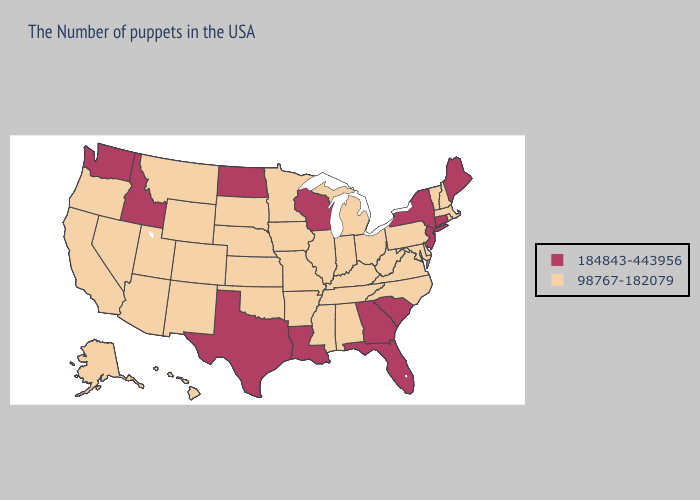Does Oregon have the same value as Minnesota?
Short answer required. Yes. Does New Jersey have the highest value in the Northeast?
Be succinct. Yes. Name the states that have a value in the range 184843-443956?
Be succinct. Maine, Connecticut, New York, New Jersey, South Carolina, Florida, Georgia, Wisconsin, Louisiana, Texas, North Dakota, Idaho, Washington. Name the states that have a value in the range 184843-443956?
Concise answer only. Maine, Connecticut, New York, New Jersey, South Carolina, Florida, Georgia, Wisconsin, Louisiana, Texas, North Dakota, Idaho, Washington. Name the states that have a value in the range 98767-182079?
Keep it brief. Massachusetts, Rhode Island, New Hampshire, Vermont, Delaware, Maryland, Pennsylvania, Virginia, North Carolina, West Virginia, Ohio, Michigan, Kentucky, Indiana, Alabama, Tennessee, Illinois, Mississippi, Missouri, Arkansas, Minnesota, Iowa, Kansas, Nebraska, Oklahoma, South Dakota, Wyoming, Colorado, New Mexico, Utah, Montana, Arizona, Nevada, California, Oregon, Alaska, Hawaii. Does Colorado have a higher value than Iowa?
Concise answer only. No. Does Idaho have the lowest value in the USA?
Answer briefly. No. Does Oklahoma have a lower value than Idaho?
Keep it brief. Yes. Which states have the lowest value in the USA?
Quick response, please. Massachusetts, Rhode Island, New Hampshire, Vermont, Delaware, Maryland, Pennsylvania, Virginia, North Carolina, West Virginia, Ohio, Michigan, Kentucky, Indiana, Alabama, Tennessee, Illinois, Mississippi, Missouri, Arkansas, Minnesota, Iowa, Kansas, Nebraska, Oklahoma, South Dakota, Wyoming, Colorado, New Mexico, Utah, Montana, Arizona, Nevada, California, Oregon, Alaska, Hawaii. Does Washington have the highest value in the West?
Short answer required. Yes. Among the states that border Louisiana , which have the lowest value?
Short answer required. Mississippi, Arkansas. What is the value of Louisiana?
Short answer required. 184843-443956. Does North Dakota have the highest value in the USA?
Give a very brief answer. Yes. Among the states that border Oregon , which have the lowest value?
Concise answer only. Nevada, California. What is the value of Louisiana?
Concise answer only. 184843-443956. 